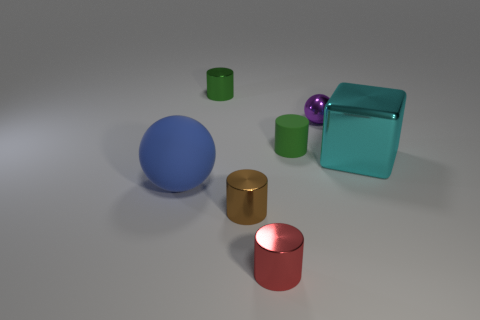Are there any cyan metal objects of the same shape as the tiny purple metallic thing?
Give a very brief answer. No. Is the small matte cylinder the same color as the tiny metal sphere?
Provide a short and direct response. No. There is a large object that is to the right of the matte thing that is to the left of the green metal object; what is its material?
Make the answer very short. Metal. The metal cube has what size?
Give a very brief answer. Large. What size is the thing that is made of the same material as the big ball?
Ensure brevity in your answer.  Small. There is a green cylinder that is to the left of the red cylinder; does it have the same size as the large block?
Make the answer very short. No. There is a large thing that is to the right of the sphere left of the small green thing that is on the left side of the tiny matte thing; what is its shape?
Your answer should be very brief. Cube. What number of things are matte spheres or big things that are on the left side of the small green shiny cylinder?
Make the answer very short. 1. What size is the green object that is to the left of the red object?
Provide a succinct answer. Small. There is a metal thing that is the same color as the small matte cylinder; what is its shape?
Provide a short and direct response. Cylinder. 